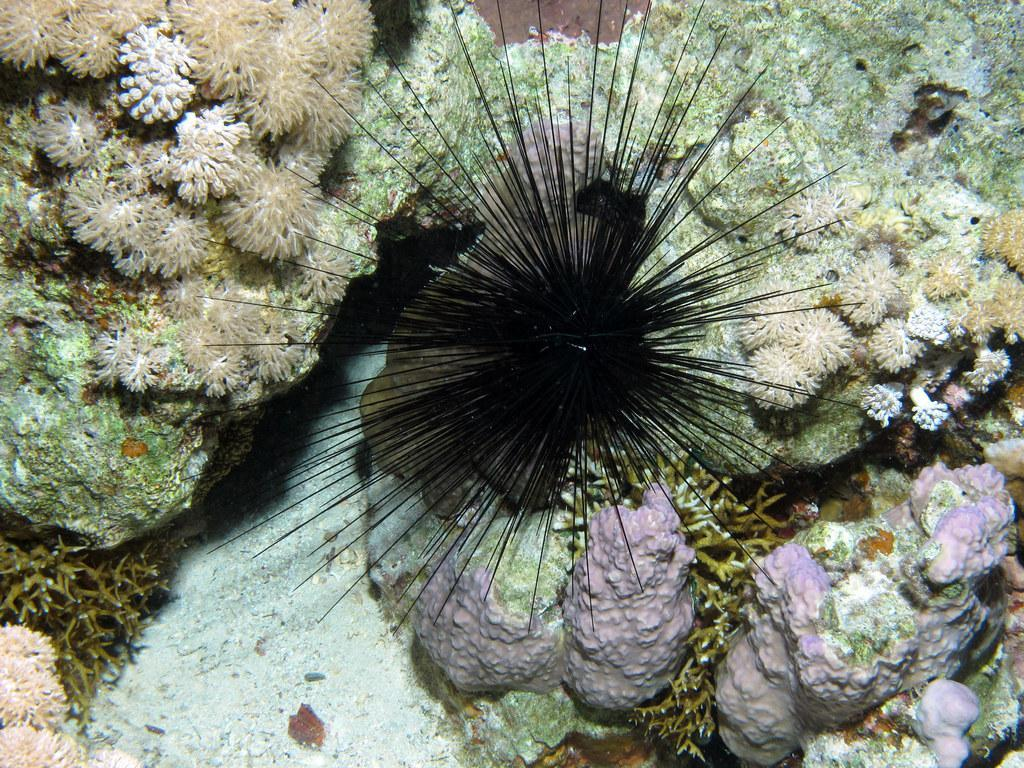What type of living organisms can be seen in the image? The image contains marine species. What type of drum can be seen in the image? There is no drum present in the image; it contains marine species. 